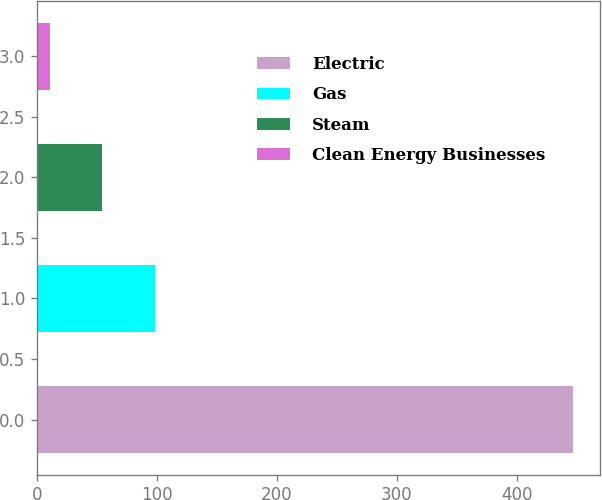<chart> <loc_0><loc_0><loc_500><loc_500><bar_chart><fcel>Electric<fcel>Gas<fcel>Steam<fcel>Clean Energy Businesses<nl><fcel>447<fcel>98.2<fcel>54.6<fcel>11<nl></chart> 